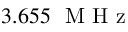<formula> <loc_0><loc_0><loc_500><loc_500>3 . 6 5 5 M H z</formula> 